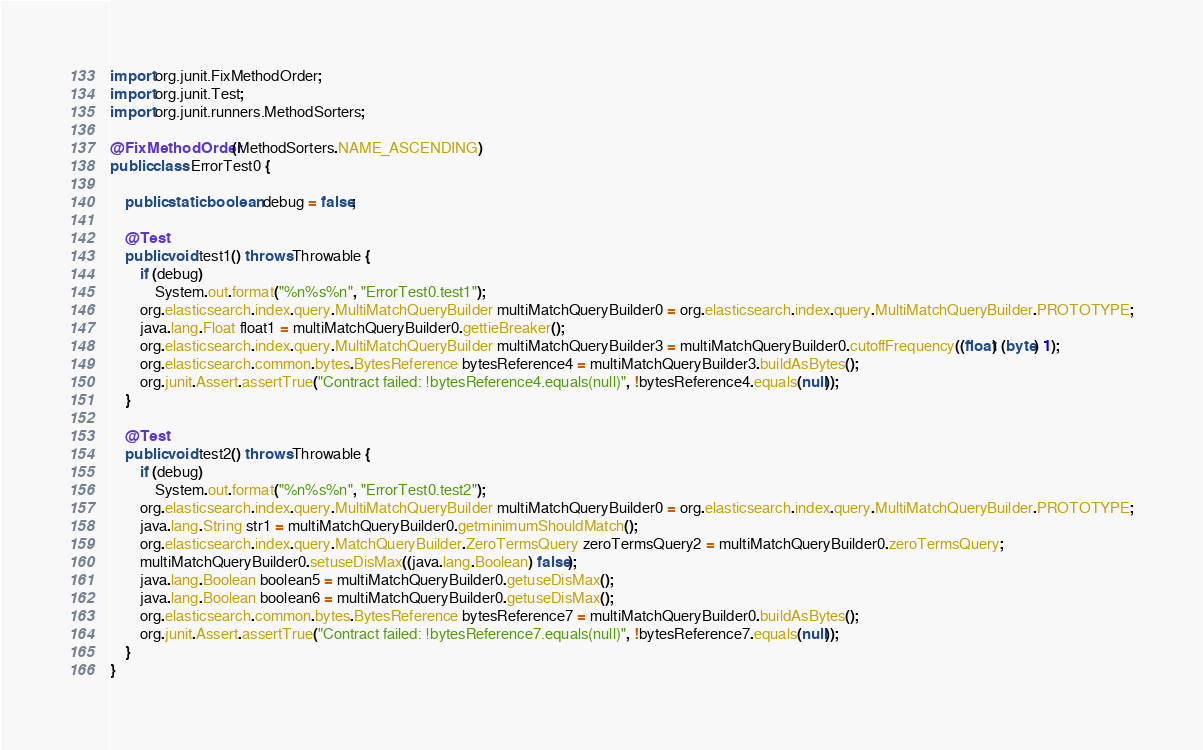Convert code to text. <code><loc_0><loc_0><loc_500><loc_500><_Java_>import org.junit.FixMethodOrder;
import org.junit.Test;
import org.junit.runners.MethodSorters;

@FixMethodOrder(MethodSorters.NAME_ASCENDING)
public class ErrorTest0 {

    public static boolean debug = false;

    @Test
    public void test1() throws Throwable {
        if (debug)
            System.out.format("%n%s%n", "ErrorTest0.test1");
        org.elasticsearch.index.query.MultiMatchQueryBuilder multiMatchQueryBuilder0 = org.elasticsearch.index.query.MultiMatchQueryBuilder.PROTOTYPE;
        java.lang.Float float1 = multiMatchQueryBuilder0.gettieBreaker();
        org.elasticsearch.index.query.MultiMatchQueryBuilder multiMatchQueryBuilder3 = multiMatchQueryBuilder0.cutoffFrequency((float) (byte) 1);
        org.elasticsearch.common.bytes.BytesReference bytesReference4 = multiMatchQueryBuilder3.buildAsBytes();
        org.junit.Assert.assertTrue("Contract failed: !bytesReference4.equals(null)", !bytesReference4.equals(null));
    }

    @Test
    public void test2() throws Throwable {
        if (debug)
            System.out.format("%n%s%n", "ErrorTest0.test2");
        org.elasticsearch.index.query.MultiMatchQueryBuilder multiMatchQueryBuilder0 = org.elasticsearch.index.query.MultiMatchQueryBuilder.PROTOTYPE;
        java.lang.String str1 = multiMatchQueryBuilder0.getminimumShouldMatch();
        org.elasticsearch.index.query.MatchQueryBuilder.ZeroTermsQuery zeroTermsQuery2 = multiMatchQueryBuilder0.zeroTermsQuery;
        multiMatchQueryBuilder0.setuseDisMax((java.lang.Boolean) false);
        java.lang.Boolean boolean5 = multiMatchQueryBuilder0.getuseDisMax();
        java.lang.Boolean boolean6 = multiMatchQueryBuilder0.getuseDisMax();
        org.elasticsearch.common.bytes.BytesReference bytesReference7 = multiMatchQueryBuilder0.buildAsBytes();
        org.junit.Assert.assertTrue("Contract failed: !bytesReference7.equals(null)", !bytesReference7.equals(null));
    }
}

</code> 